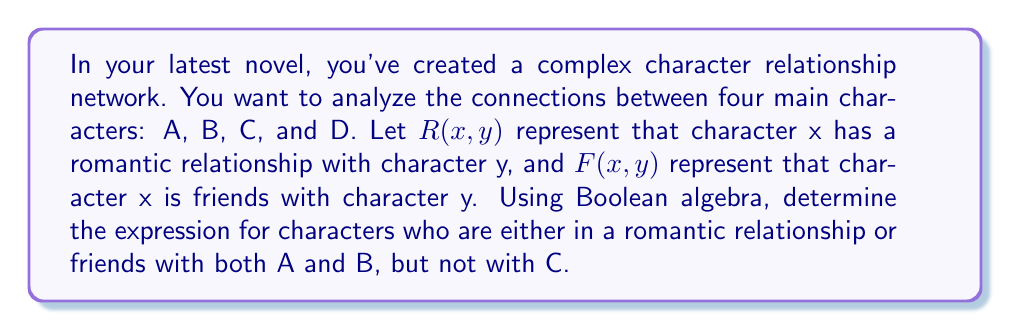Give your solution to this math problem. To solve this problem, we'll use Boolean algebra operations to construct the expression step-by-step:

1. Let's define the set of characters who have a romantic relationship or friendship with A:
   $$(R(x,A) \lor F(x,A))$$

2. Similarly, for character B:
   $$(R(x,B) \lor F(x,B))$$

3. We want characters who have this relationship with both A and B, so we use the AND operation:
   $$(R(x,A) \lor F(x,A)) \land (R(x,B) \lor F(x,B))$$

4. Now, we need to exclude characters who have a relationship with C. We can represent this as the negation of having any relationship with C:
   $$\lnot(R(x,C) \lor F(x,C))$$

5. Combining all these conditions using the AND operation, we get:
   $$((R(x,A) \lor F(x,A)) \land (R(x,B) \lor F(x,B))) \land \lnot(R(x,C) \lor F(x,C))$$

6. This expression represents characters who are either in a romantic relationship or friends with both A and B, but not with C.

7. We can simplify this expression using the distributive property:
   $$(R(x,A) \land R(x,B) \lor R(x,A) \land F(x,B) \lor F(x,A) \land R(x,B) \lor F(x,A) \land F(x,B)) \land \lnot(R(x,C) \lor F(x,C))$$

This final expression represents the Boolean algebra solution for the character relationship network described in the question.
Answer: $$(R(x,A) \land R(x,B) \lor R(x,A) \land F(x,B) \lor F(x,A) \land R(x,B) \lor F(x,A) \land F(x,B)) \land \lnot(R(x,C) \lor F(x,C))$$ 